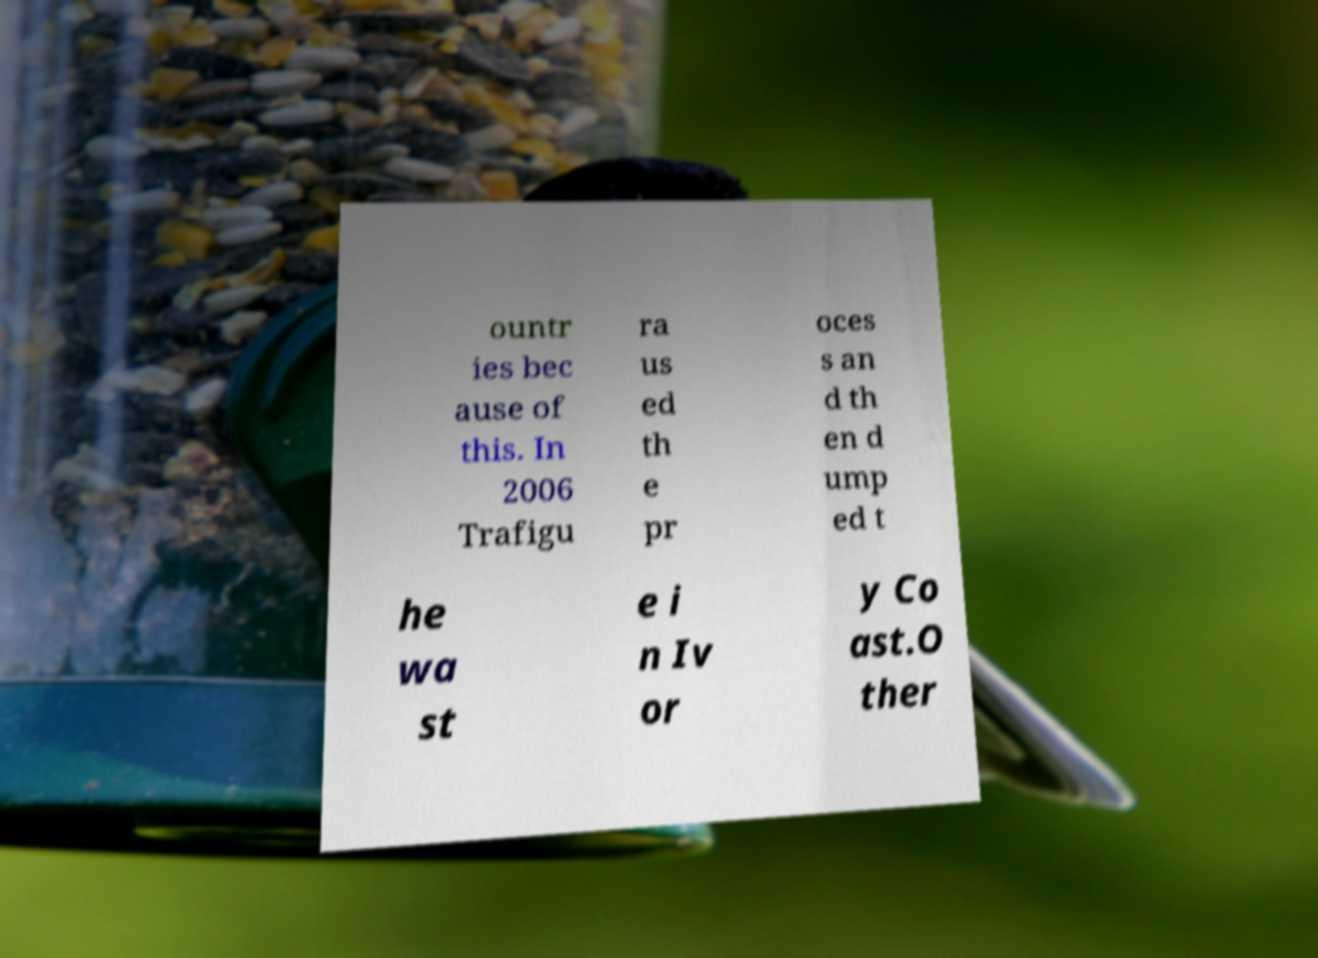Please identify and transcribe the text found in this image. ountr ies bec ause of this. In 2006 Trafigu ra us ed th e pr oces s an d th en d ump ed t he wa st e i n Iv or y Co ast.O ther 